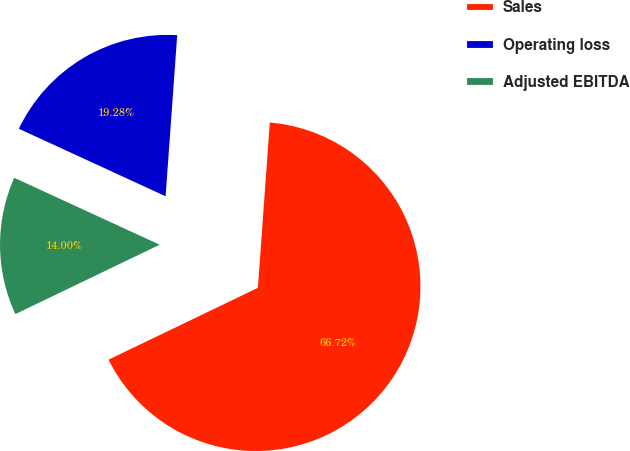Convert chart to OTSL. <chart><loc_0><loc_0><loc_500><loc_500><pie_chart><fcel>Sales<fcel>Operating loss<fcel>Adjusted EBITDA<nl><fcel>66.72%<fcel>19.28%<fcel>14.0%<nl></chart> 